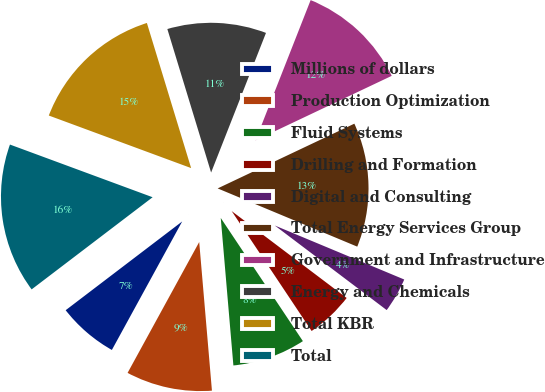Convert chart to OTSL. <chart><loc_0><loc_0><loc_500><loc_500><pie_chart><fcel>Millions of dollars<fcel>Production Optimization<fcel>Fluid Systems<fcel>Drilling and Formation<fcel>Digital and Consulting<fcel>Total Energy Services Group<fcel>Government and Infrastructure<fcel>Energy and Chemicals<fcel>Total KBR<fcel>Total<nl><fcel>6.67%<fcel>9.33%<fcel>8.0%<fcel>5.34%<fcel>4.01%<fcel>13.33%<fcel>12.0%<fcel>10.67%<fcel>14.66%<fcel>15.99%<nl></chart> 